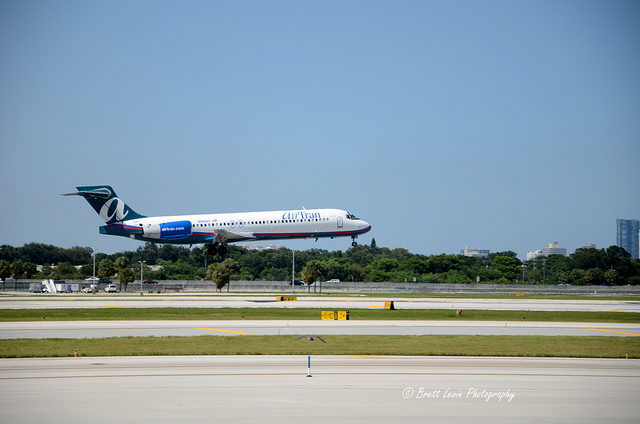Please identify all text content in this image. a Photography 